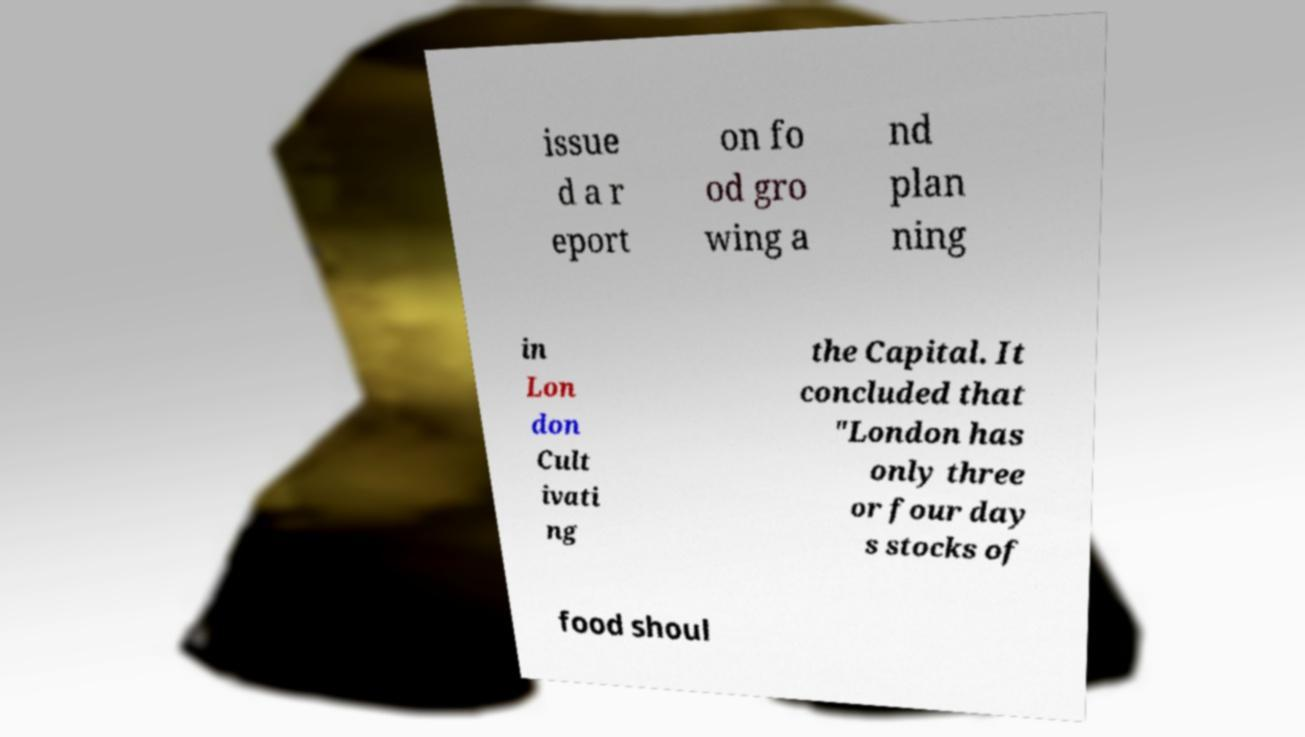There's text embedded in this image that I need extracted. Can you transcribe it verbatim? issue d a r eport on fo od gro wing a nd plan ning in Lon don Cult ivati ng the Capital. It concluded that "London has only three or four day s stocks of food shoul 